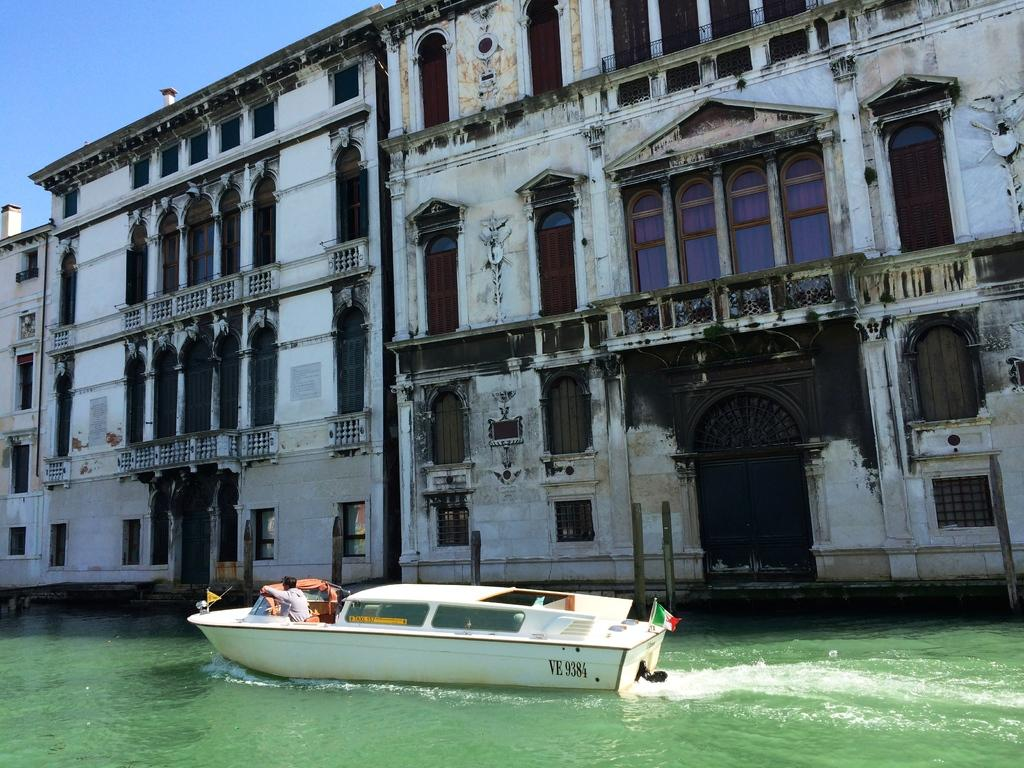Provide a one-sentence caption for the provided image. VE 9384 white boat in the water with a Italy flag on back. 